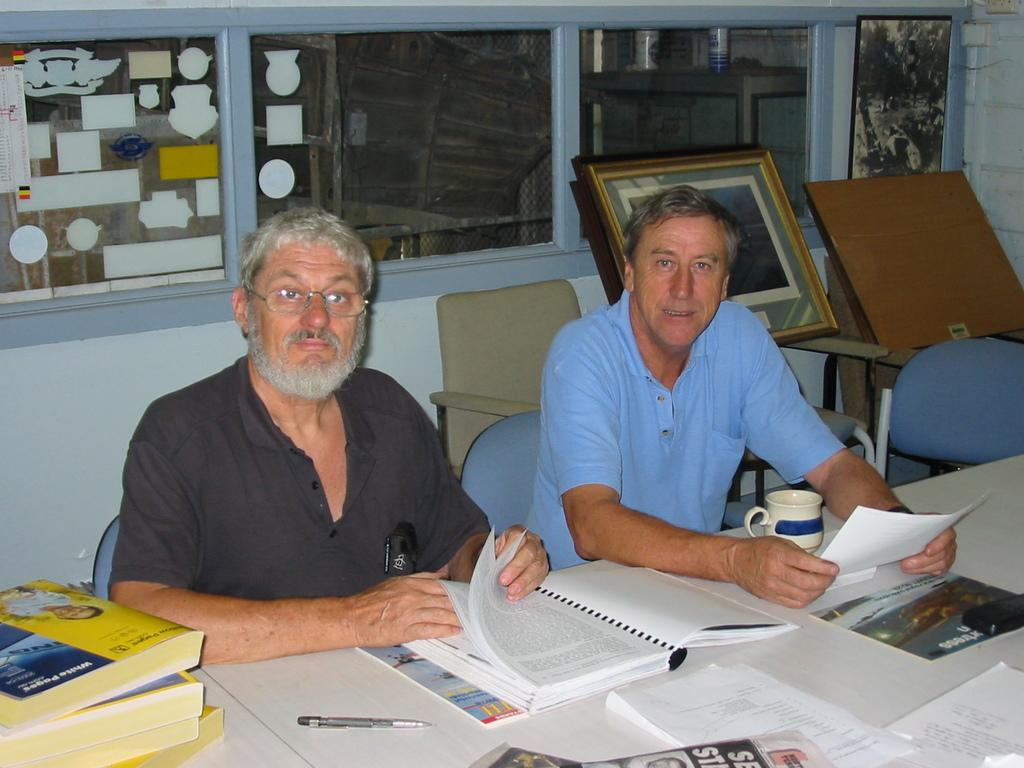How many people are sitting in chairs in the image? There are two persons sitting in chairs in the image. What is on the table in the image? There is a book, a paper, a pen, and a cup on the table in the image. What can be seen in the background of the image? There is a frame, a chair, and a wall in the background of the image. What type of toys can be seen on the table in the image? There are no toys present on the table in the image. What experience can be gained from the truck in the image? There is no truck present in the image, so no experience can be gained from it. 